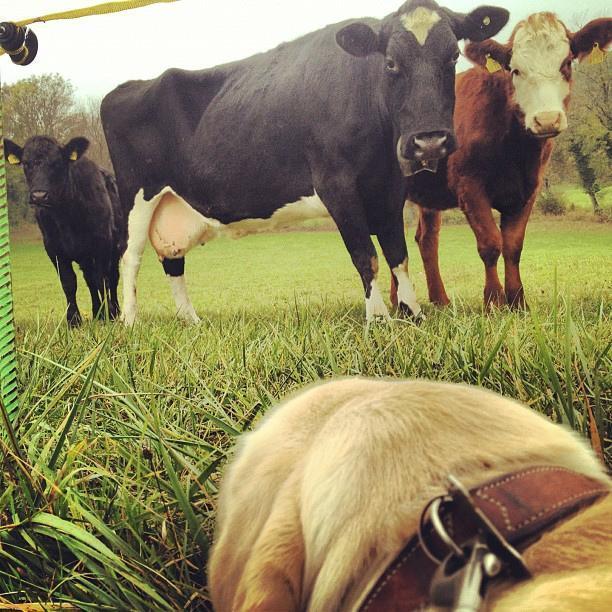How many species of animals are in the picture?
Give a very brief answer. 2. How many cows are visible?
Give a very brief answer. 3. How many people are in the photo?
Give a very brief answer. 0. 